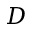<formula> <loc_0><loc_0><loc_500><loc_500>D</formula> 